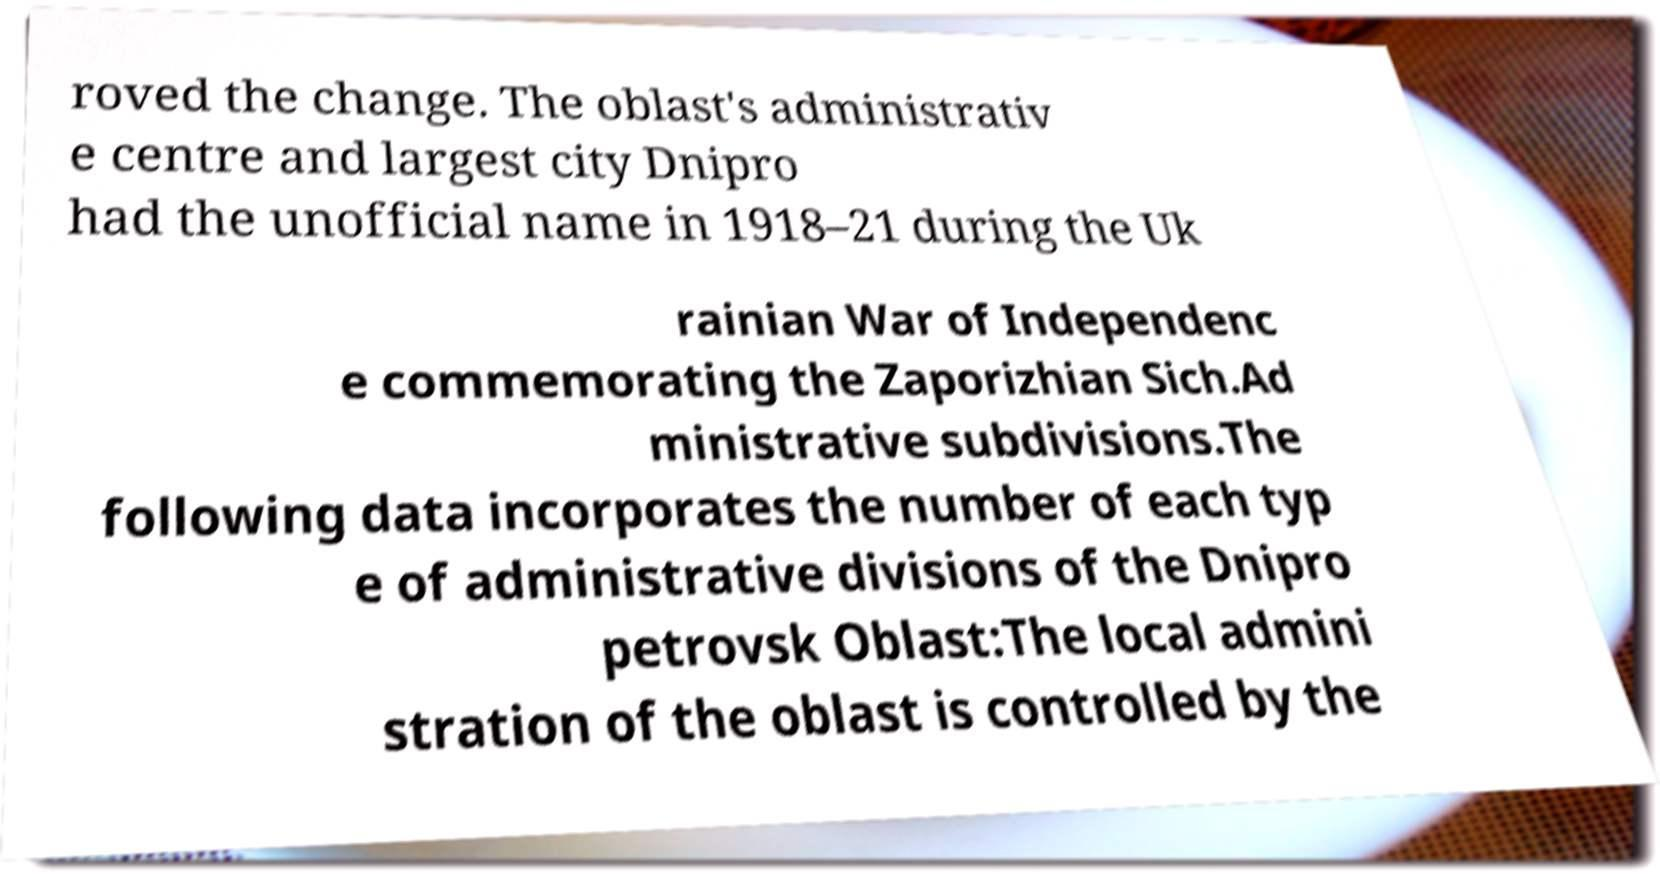For documentation purposes, I need the text within this image transcribed. Could you provide that? roved the change. The oblast's administrativ e centre and largest city Dnipro had the unofficial name in 1918–21 during the Uk rainian War of Independenc e commemorating the Zaporizhian Sich.Ad ministrative subdivisions.The following data incorporates the number of each typ e of administrative divisions of the Dnipro petrovsk Oblast:The local admini stration of the oblast is controlled by the 